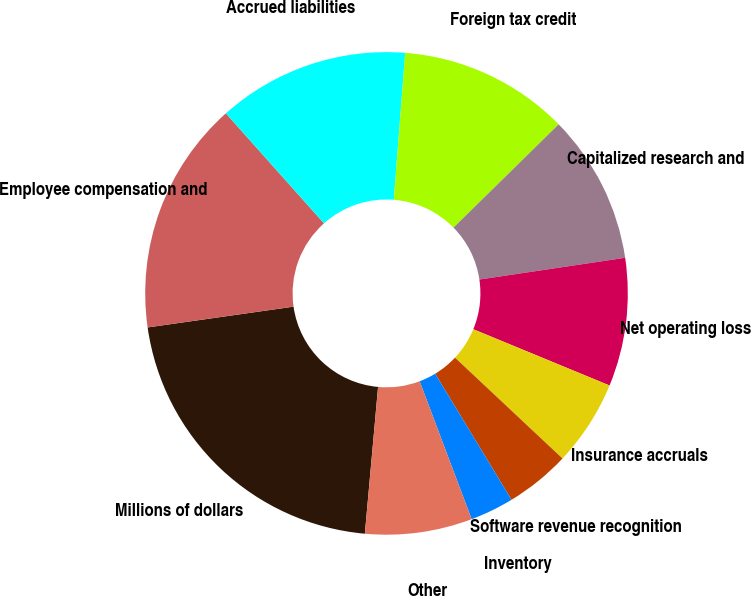<chart> <loc_0><loc_0><loc_500><loc_500><pie_chart><fcel>Millions of dollars<fcel>Employee compensation and<fcel>Accrued liabilities<fcel>Foreign tax credit<fcel>Capitalized research and<fcel>Net operating loss<fcel>Insurance accruals<fcel>Software revenue recognition<fcel>Inventory<fcel>Other<nl><fcel>21.32%<fcel>15.66%<fcel>12.83%<fcel>11.41%<fcel>10.0%<fcel>8.59%<fcel>5.76%<fcel>4.34%<fcel>2.93%<fcel>7.17%<nl></chart> 